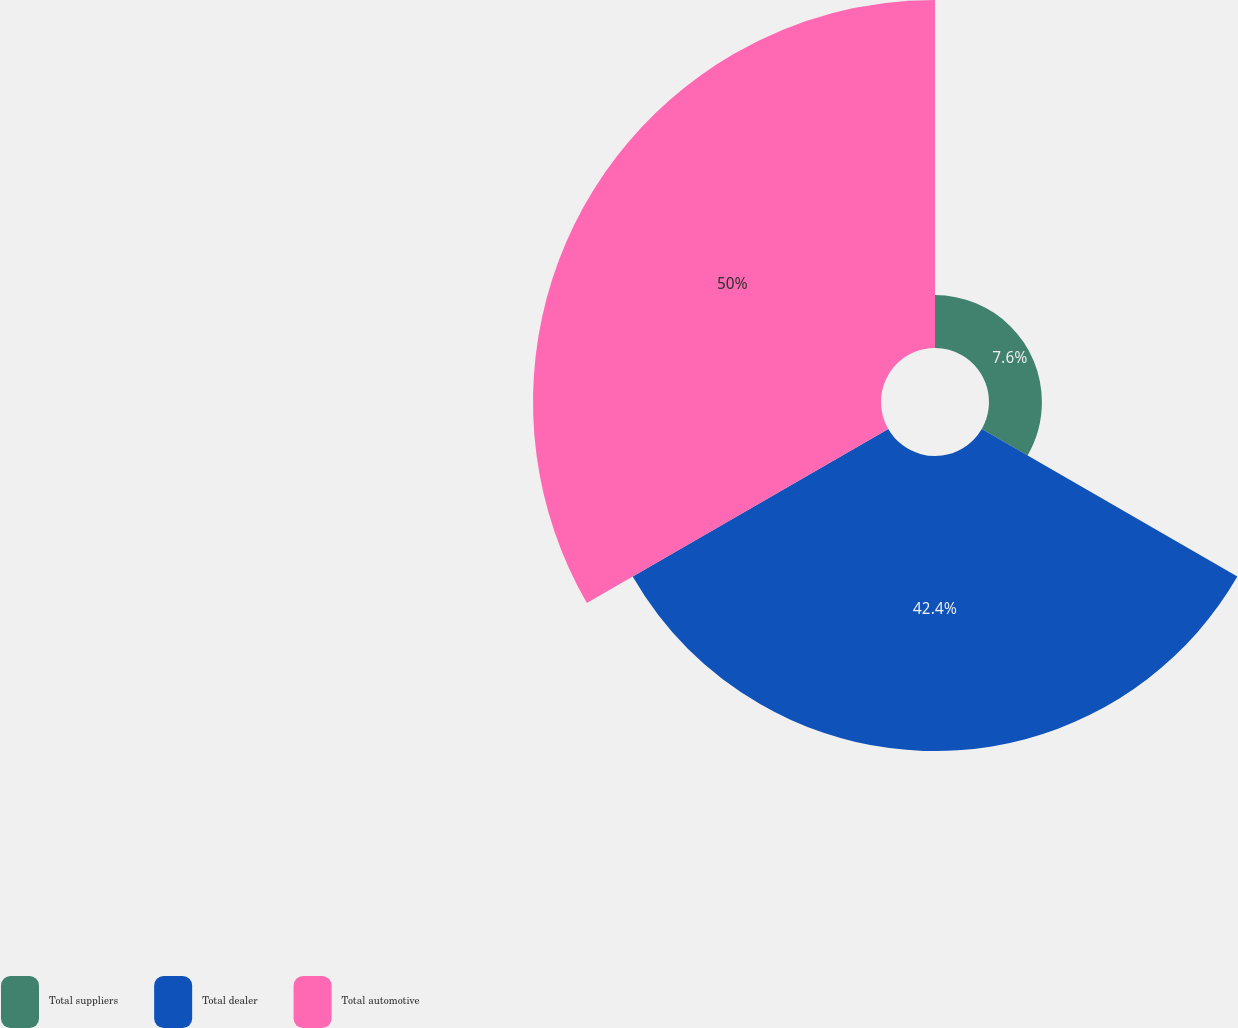Convert chart. <chart><loc_0><loc_0><loc_500><loc_500><pie_chart><fcel>Total suppliers<fcel>Total dealer<fcel>Total automotive<nl><fcel>7.6%<fcel>42.4%<fcel>50.0%<nl></chart> 